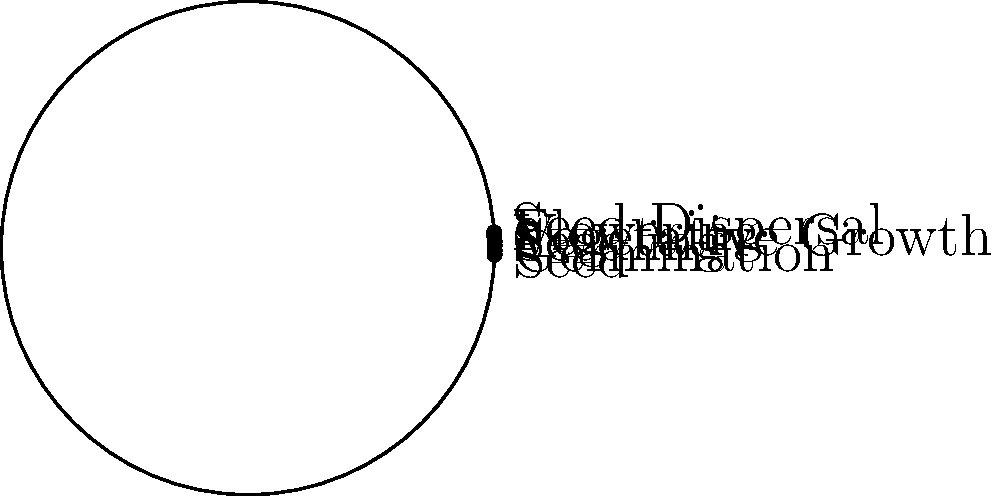In the life cycle of a grass plant, which stage immediately follows the flowering phase? To answer this question, we need to understand the life cycle of a grass plant and the order of its stages:

1. The life cycle of a grass plant typically consists of six main stages: Seed, Germination, Seedling, Vegetative Growth, Flowering, and Seed Dispersal.

2. These stages form a continuous cycle, with each stage leading to the next.

3. In the circular diagram, we can see that the stages are arranged in a clockwise order.

4. The Flowering stage is clearly visible in the diagram.

5. Following the clockwise direction, we can observe that the stage immediately after Flowering is Seed Dispersal.

6. This makes biological sense because after the grass plant flowers and is pollinated, it produces seeds which are then dispersed to start the cycle anew.

Therefore, the stage that immediately follows the flowering phase in the life cycle of a grass plant is Seed Dispersal.
Answer: Seed Dispersal 